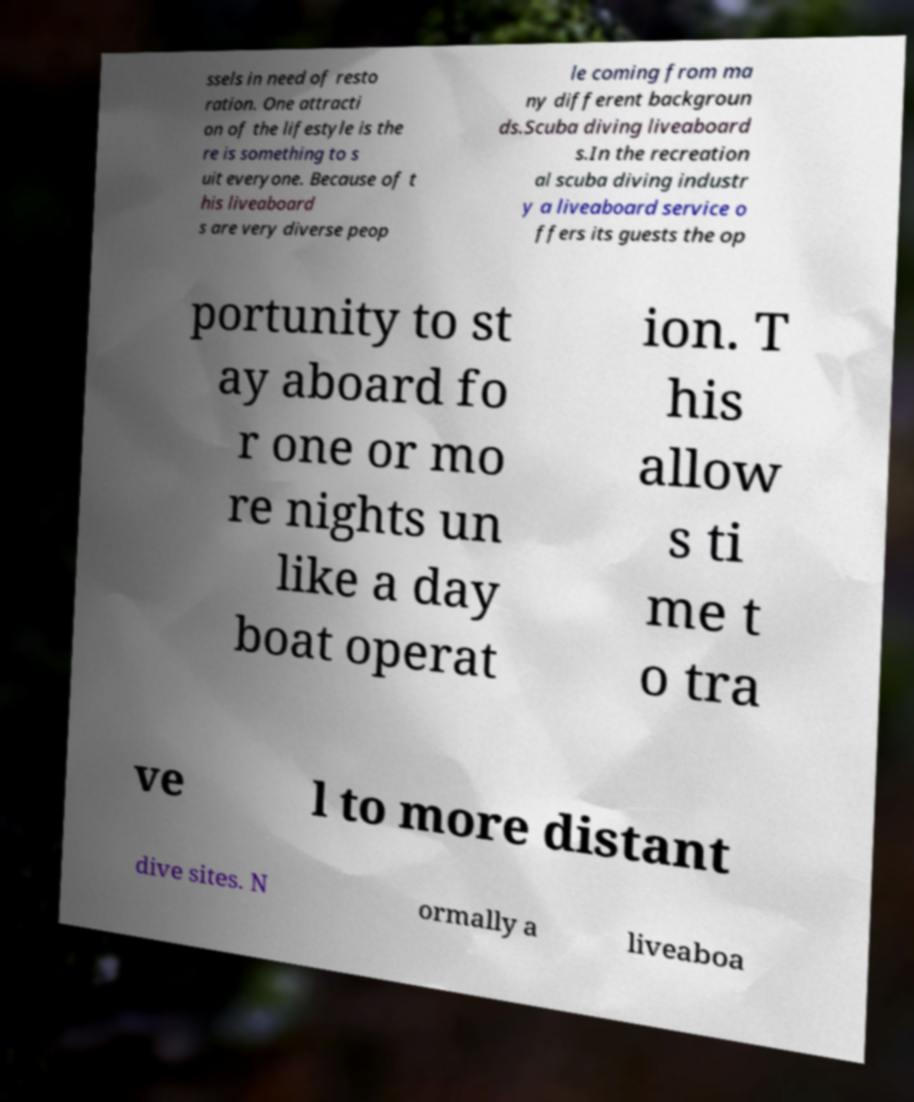Please identify and transcribe the text found in this image. ssels in need of resto ration. One attracti on of the lifestyle is the re is something to s uit everyone. Because of t his liveaboard s are very diverse peop le coming from ma ny different backgroun ds.Scuba diving liveaboard s.In the recreation al scuba diving industr y a liveaboard service o ffers its guests the op portunity to st ay aboard fo r one or mo re nights un like a day boat operat ion. T his allow s ti me t o tra ve l to more distant dive sites. N ormally a liveaboa 